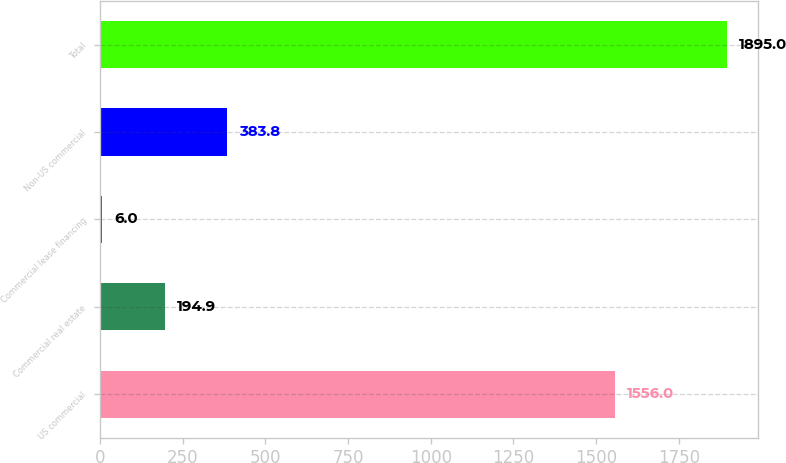<chart> <loc_0><loc_0><loc_500><loc_500><bar_chart><fcel>US commercial<fcel>Commercial real estate<fcel>Commercial lease financing<fcel>Non-US commercial<fcel>Total<nl><fcel>1556<fcel>194.9<fcel>6<fcel>383.8<fcel>1895<nl></chart> 